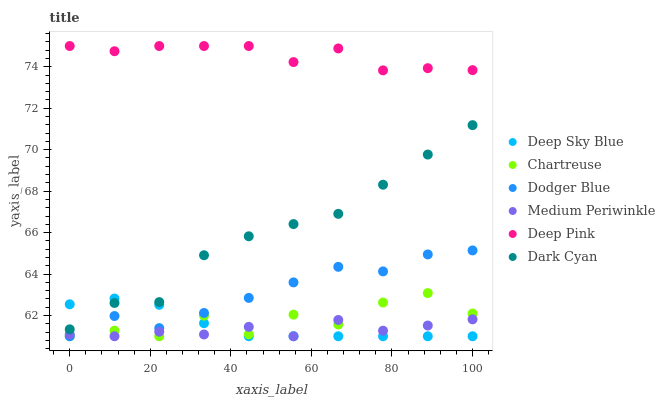Does Medium Periwinkle have the minimum area under the curve?
Answer yes or no. Yes. Does Deep Pink have the maximum area under the curve?
Answer yes or no. Yes. Does Chartreuse have the minimum area under the curve?
Answer yes or no. No. Does Chartreuse have the maximum area under the curve?
Answer yes or no. No. Is Deep Sky Blue the smoothest?
Answer yes or no. Yes. Is Chartreuse the roughest?
Answer yes or no. Yes. Is Medium Periwinkle the smoothest?
Answer yes or no. No. Is Medium Periwinkle the roughest?
Answer yes or no. No. Does Medium Periwinkle have the lowest value?
Answer yes or no. Yes. Does Dark Cyan have the lowest value?
Answer yes or no. No. Does Deep Pink have the highest value?
Answer yes or no. Yes. Does Chartreuse have the highest value?
Answer yes or no. No. Is Dark Cyan less than Deep Pink?
Answer yes or no. Yes. Is Deep Pink greater than Dark Cyan?
Answer yes or no. Yes. Does Deep Sky Blue intersect Chartreuse?
Answer yes or no. Yes. Is Deep Sky Blue less than Chartreuse?
Answer yes or no. No. Is Deep Sky Blue greater than Chartreuse?
Answer yes or no. No. Does Dark Cyan intersect Deep Pink?
Answer yes or no. No. 